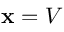<formula> <loc_0><loc_0><loc_500><loc_500>x = V</formula> 